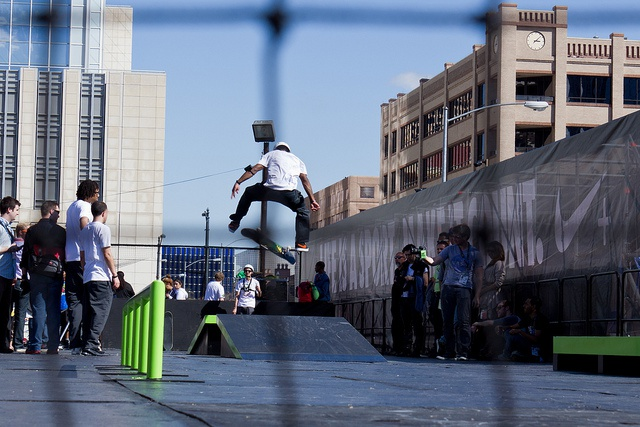Describe the objects in this image and their specific colors. I can see people in gray, black, navy, and darkblue tones, people in gray, black, and lightgray tones, people in gray, black, navy, and darkblue tones, people in gray, black, lavender, and darkgray tones, and people in gray, black, blue, and lightgray tones in this image. 